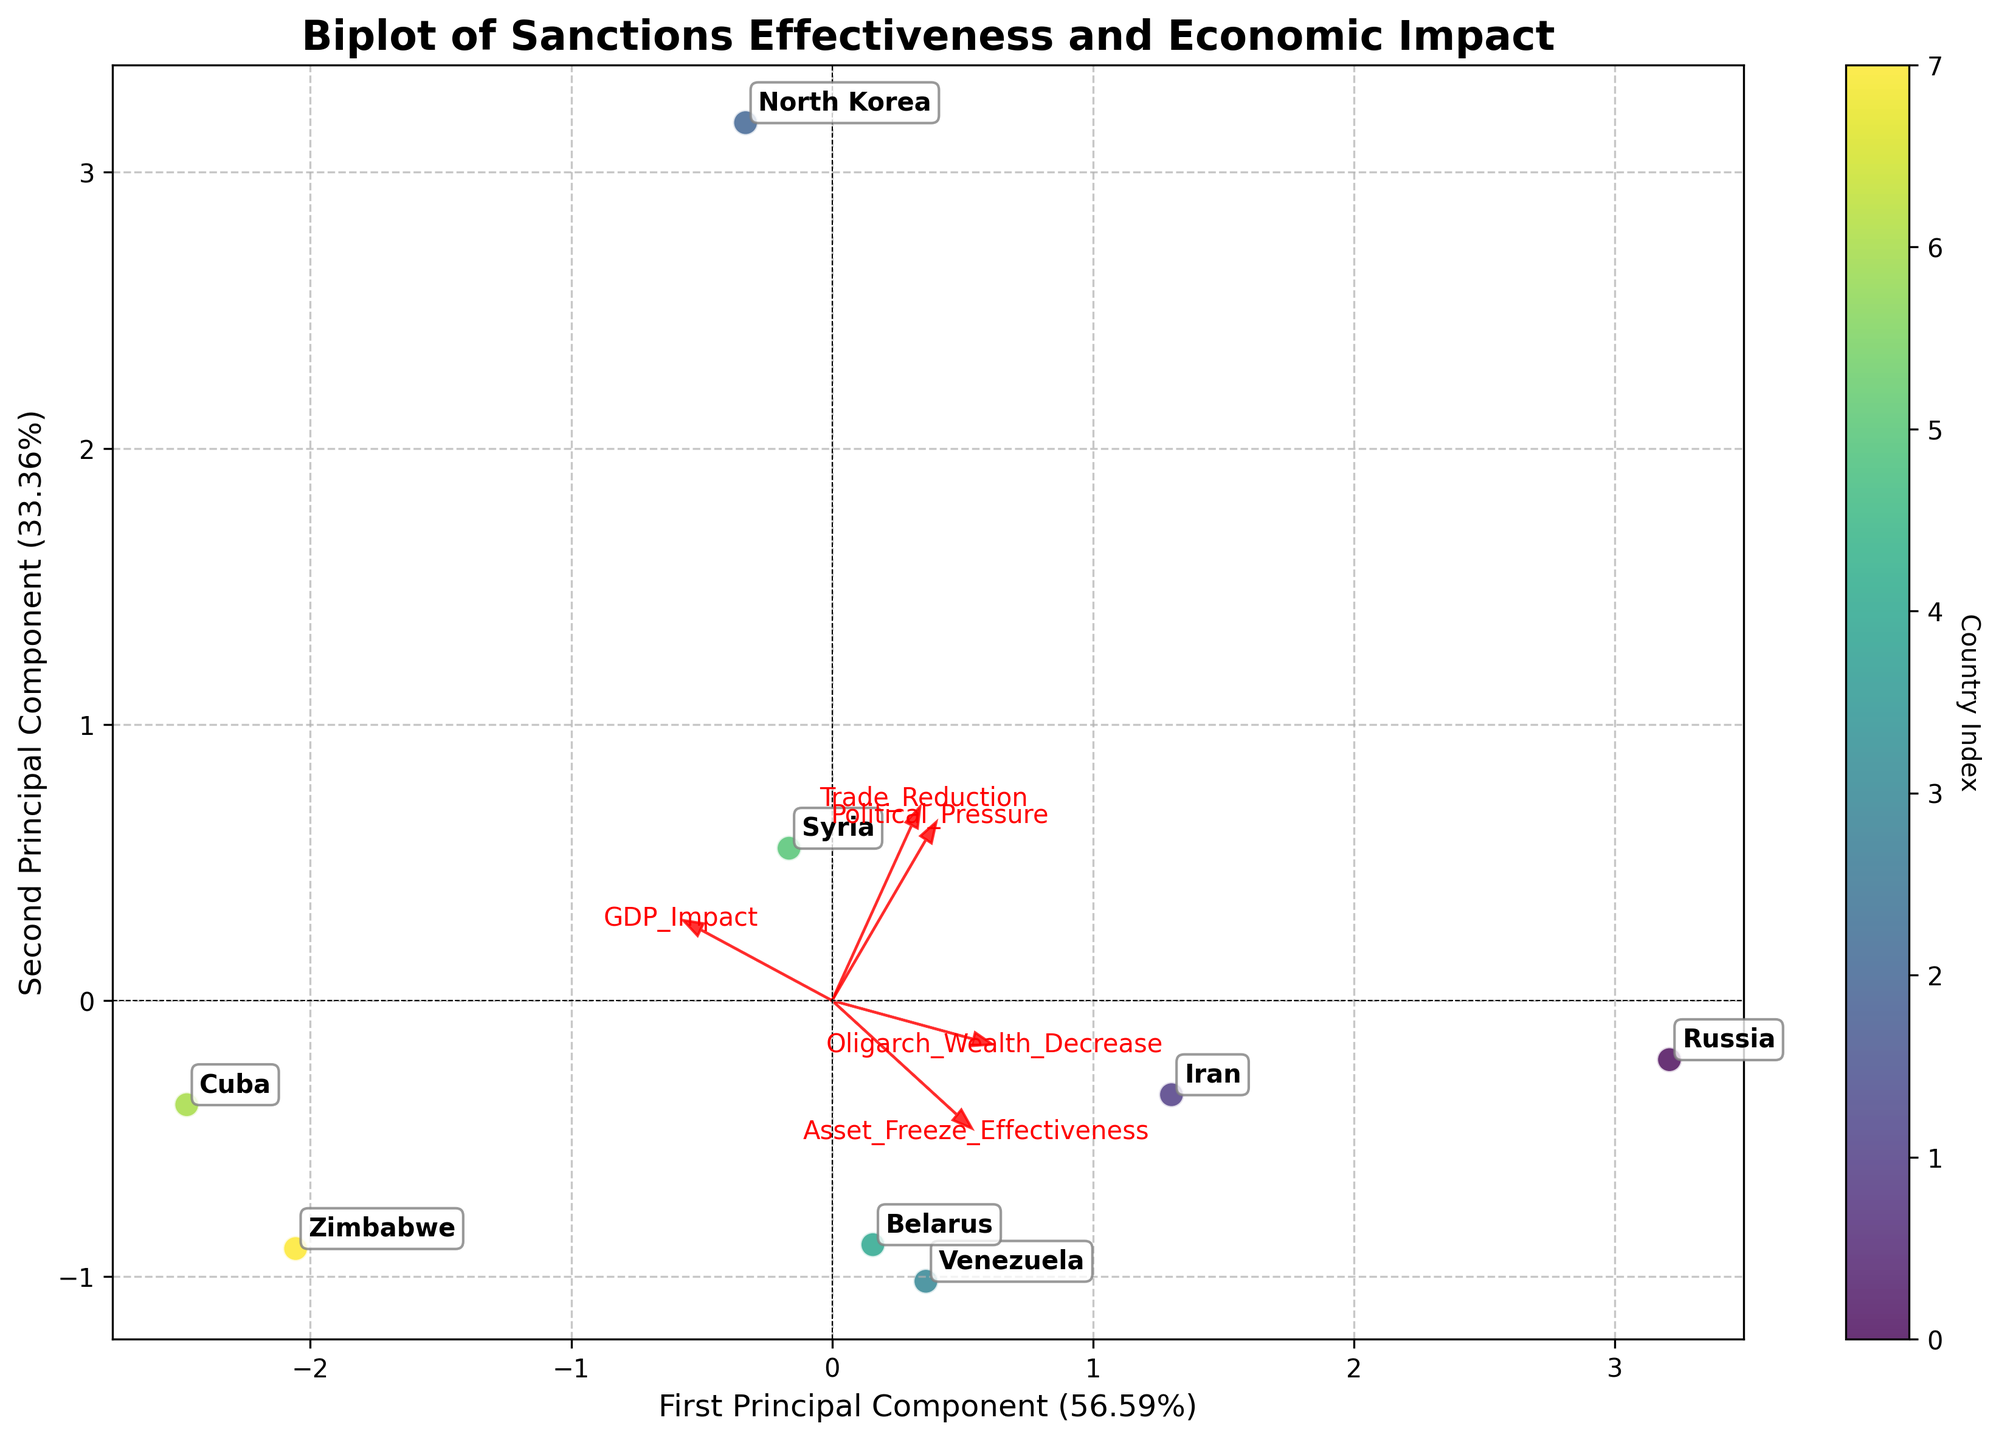How many countries are represented in the biplot? To count the number of countries, look for the number of unique labels annotated on the plot. Each label corresponds to a country in the dataset.
Answer: 8 Which country has the highest value on the first principal component? Locate the country positioned farthest to the right on the X-axis, indicating the highest value of the first principal component.
Answer: North Korea What percentage of the total variance is explained by the first two principal components combined? Add the explained variance ratios of the first and second principal components, indicated on the X and Y labels, respectively.
Answer: Approximately 100% Identify the country closest to the origin (0, 0) on the biplot. Find the country label that is nearest to the coordinates (0, 0) based on its position in the plot.
Answer: Iran Which feature has the largest loading on the second principal component? Look for the feature arrow that extends furthest in the Y-direction, or check the text representing the feature that is placed the highest along the Y-axis.
Answer: Political_Pressure Compare the positions of Russia and Venezuela on the biplot. Which one is closer to the positive side of the first principal component? Observe the relative positions of Russia and Venezuela along the X-axis and determine which one is closer to the positive side.
Answer: Venezuela Which feature appears to have the least influence on both principal components? Examine the arrows that represent the features; the shortest arrow suggests the least influence on the principal components.
Answer: GDP_Impact Are there any countries that have a negative value on both principal components? If so, name them. Identify the countries located in the quadrant where both the X and Y values are negative.
Answer: Venezuela, Cuba Which feature is most strongly correlated with the first principal component? Identify the feature whose arrow is longest and closest to the X-axis (first principal component).
Answer: Trade_Reduction 